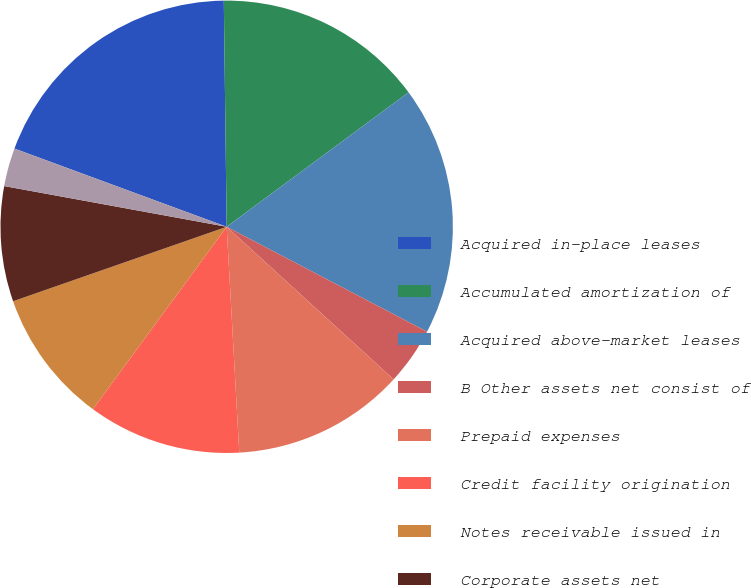Convert chart to OTSL. <chart><loc_0><loc_0><loc_500><loc_500><pie_chart><fcel>Acquired in-place leases<fcel>Accumulated amortization of<fcel>Acquired above-market leases<fcel>B Other assets net consist of<fcel>Prepaid expenses<fcel>Credit facility origination<fcel>Notes receivable issued in<fcel>Corporate assets net<fcel>Impounds related to mortgages<nl><fcel>19.18%<fcel>15.07%<fcel>17.81%<fcel>4.11%<fcel>12.33%<fcel>10.96%<fcel>9.59%<fcel>8.22%<fcel>2.74%<nl></chart> 